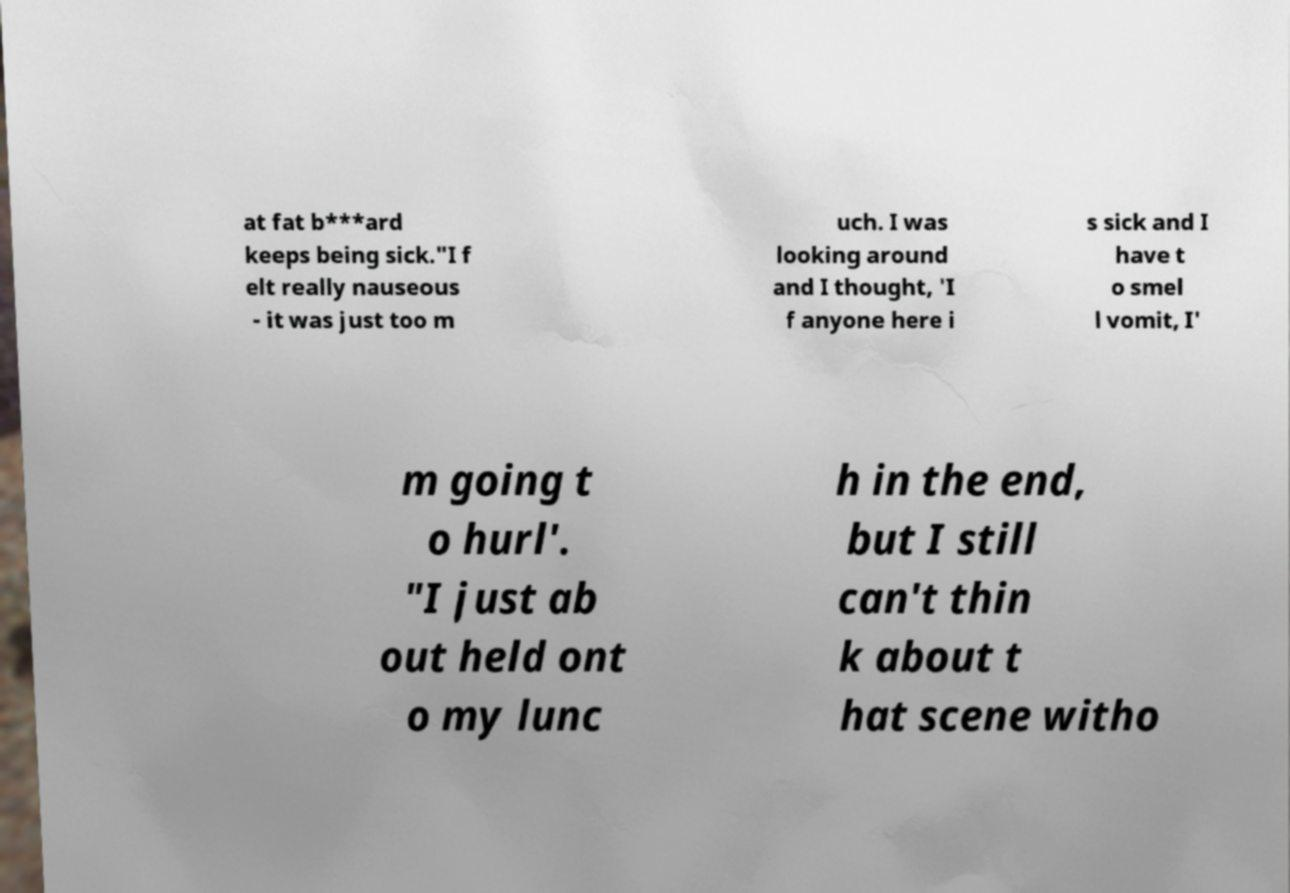I need the written content from this picture converted into text. Can you do that? at fat b***ard keeps being sick."I f elt really nauseous - it was just too m uch. I was looking around and I thought, 'I f anyone here i s sick and I have t o smel l vomit, I' m going t o hurl'. "I just ab out held ont o my lunc h in the end, but I still can't thin k about t hat scene witho 